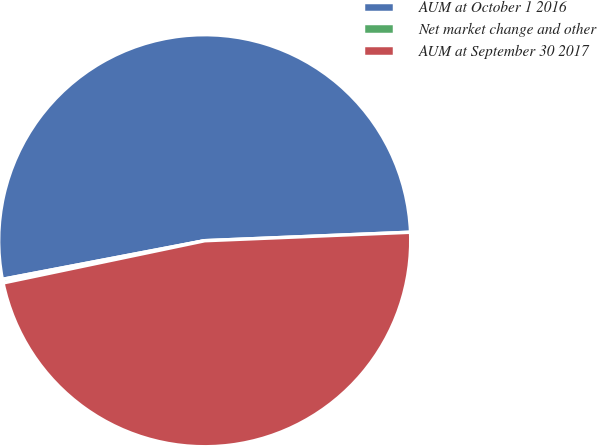Convert chart. <chart><loc_0><loc_0><loc_500><loc_500><pie_chart><fcel>AUM at October 1 2016<fcel>Net market change and other<fcel>AUM at September 30 2017<nl><fcel>52.35%<fcel>0.28%<fcel>47.37%<nl></chart> 